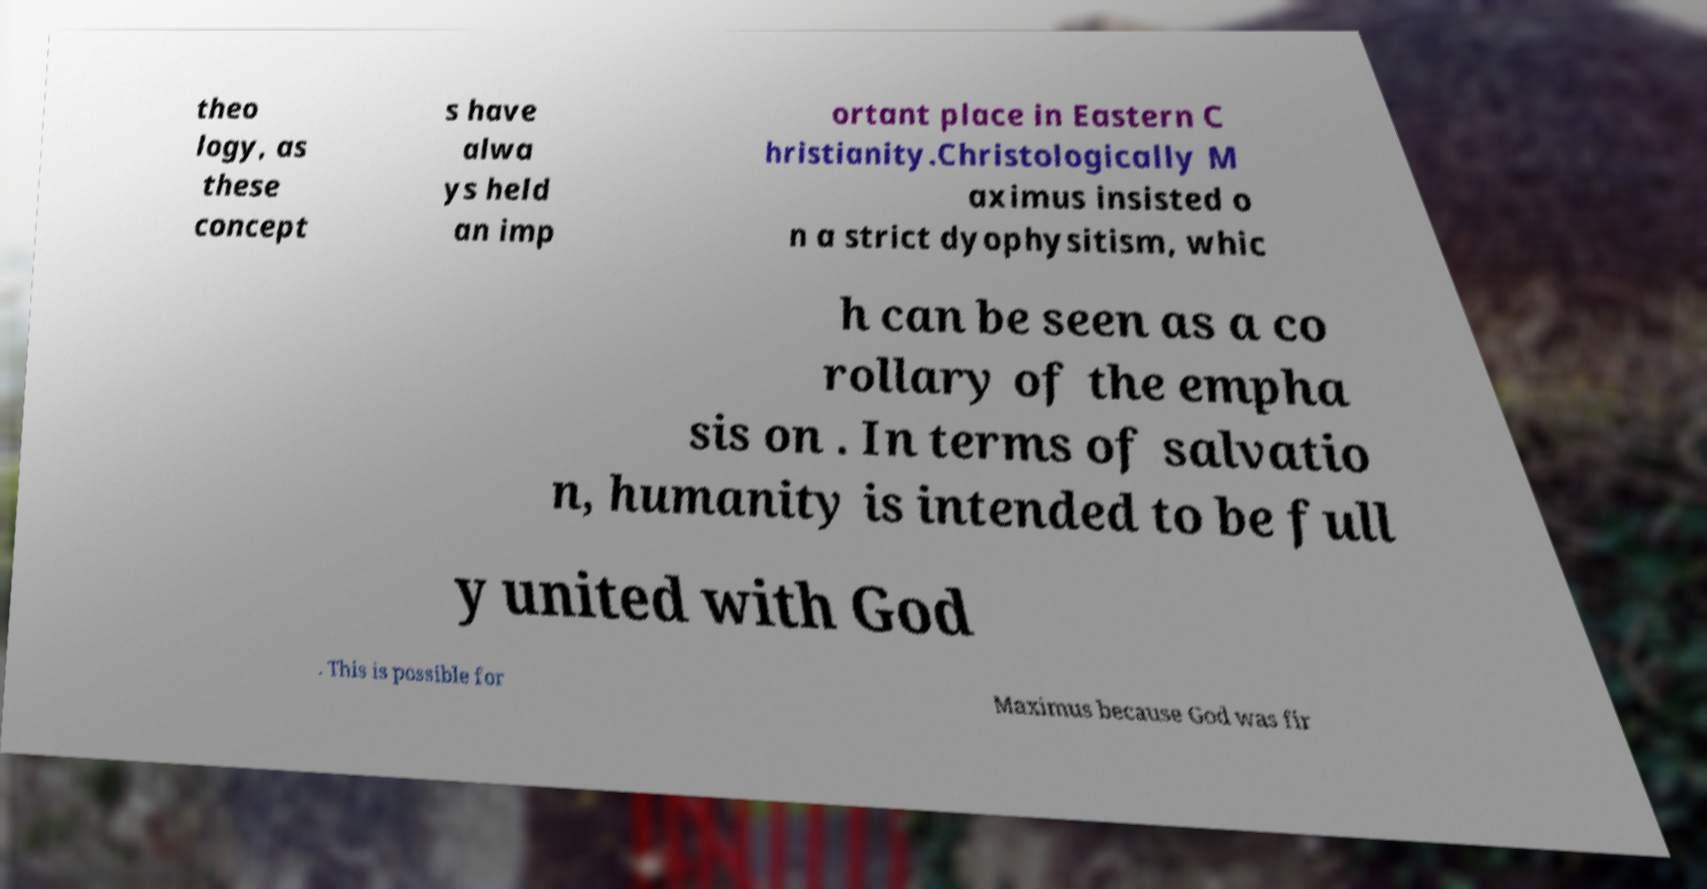Please identify and transcribe the text found in this image. theo logy, as these concept s have alwa ys held an imp ortant place in Eastern C hristianity.Christologically M aximus insisted o n a strict dyophysitism, whic h can be seen as a co rollary of the empha sis on . In terms of salvatio n, humanity is intended to be full y united with God . This is possible for Maximus because God was fir 